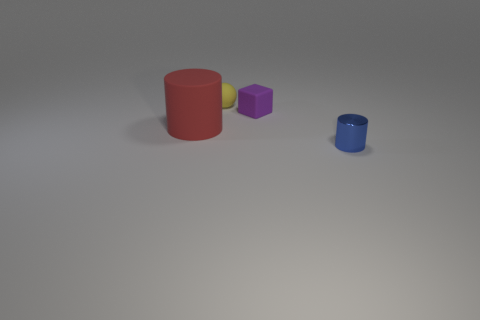Is there a large red thing that has the same material as the big cylinder?
Your answer should be compact. No. The small thing that is in front of the cylinder that is to the left of the rubber object that is behind the tiny purple matte block is what shape?
Provide a succinct answer. Cylinder. There is a small object on the right side of the block; is it the same color as the cylinder behind the blue thing?
Offer a very short reply. No. Is there any other thing that is the same size as the red matte object?
Ensure brevity in your answer.  No. There is a small shiny cylinder; are there any tiny blue metallic objects left of it?
Make the answer very short. No. How many tiny blue shiny things have the same shape as the yellow object?
Make the answer very short. 0. What is the color of the cylinder behind the cylinder that is in front of the cylinder on the left side of the small sphere?
Make the answer very short. Red. Is the material of the small object to the left of the tiny block the same as the tiny thing that is on the right side of the tiny cube?
Provide a short and direct response. No. How many objects are matte things that are to the right of the tiny rubber ball or matte balls?
Offer a very short reply. 2. How many things are cyan metal spheres or tiny objects that are behind the tiny blue shiny object?
Offer a terse response. 2. 